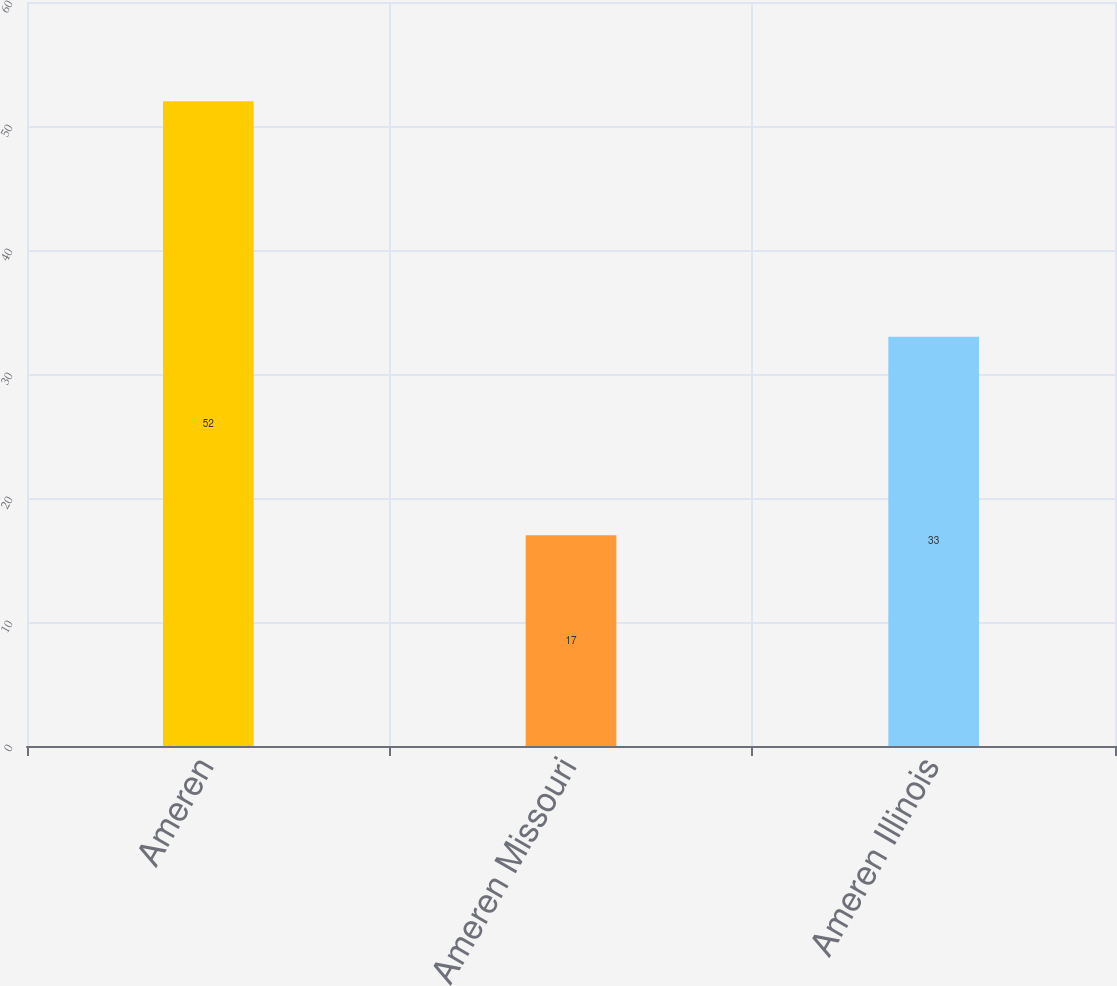Convert chart. <chart><loc_0><loc_0><loc_500><loc_500><bar_chart><fcel>Ameren<fcel>Ameren Missouri<fcel>Ameren Illinois<nl><fcel>52<fcel>17<fcel>33<nl></chart> 